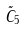<formula> <loc_0><loc_0><loc_500><loc_500>\tilde { C } _ { 5 }</formula> 